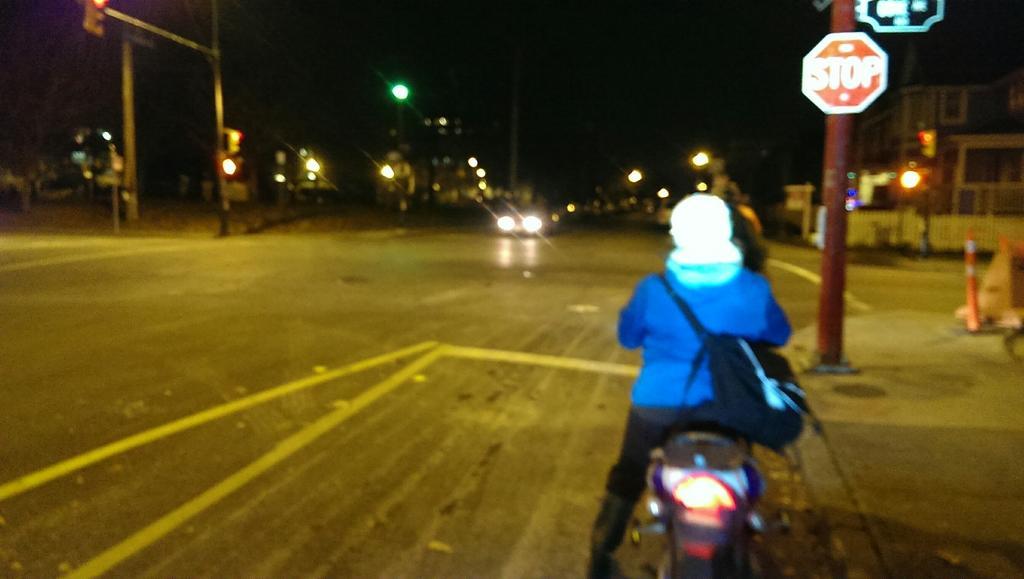Please provide a concise description of this image. In this picture we can see a person is sitting on a bike, on the right side we can see a pole, two boards, a building and traffic lights, there is a vehicle traveling on the road, in the background there are some lights, buildings and poles, we can see a dark background. 